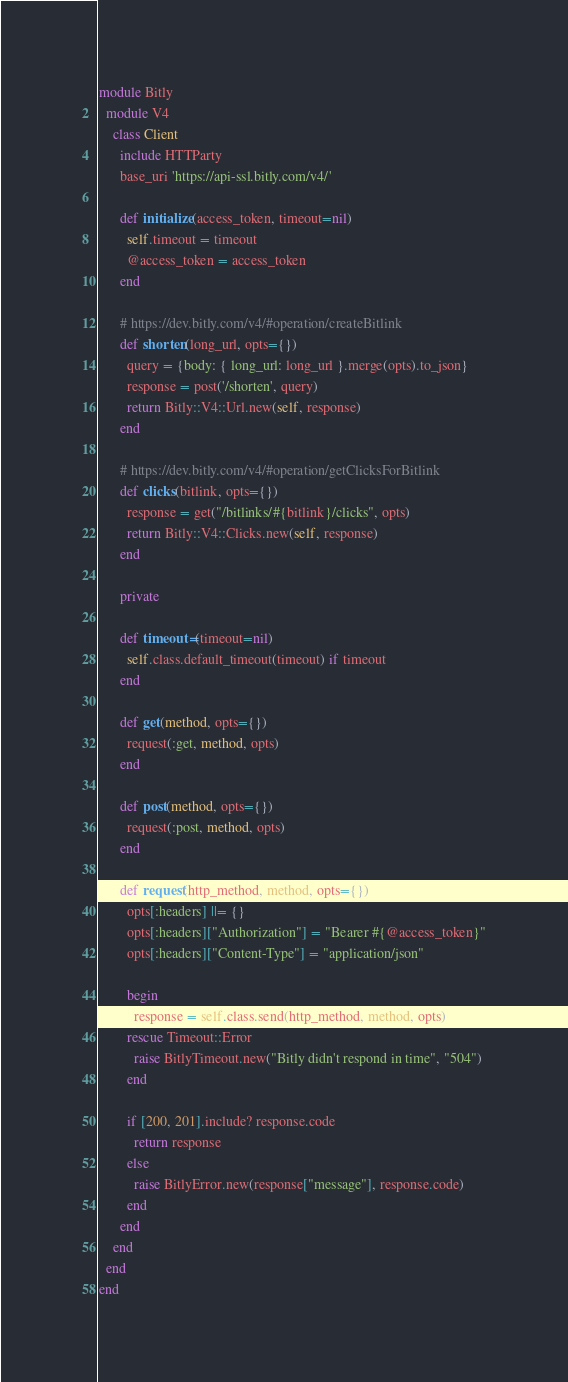Convert code to text. <code><loc_0><loc_0><loc_500><loc_500><_Ruby_>module Bitly
  module V4
    class Client
      include HTTParty
      base_uri 'https://api-ssl.bitly.com/v4/'

      def initialize(access_token, timeout=nil)
        self.timeout = timeout
        @access_token = access_token
      end

      # https://dev.bitly.com/v4/#operation/createBitlink
      def shorten(long_url, opts={})
        query = {body: { long_url: long_url }.merge(opts).to_json}
        response = post('/shorten', query)
        return Bitly::V4::Url.new(self, response)
      end

      # https://dev.bitly.com/v4/#operation/getClicksForBitlink
      def clicks(bitlink, opts={})
        response = get("/bitlinks/#{bitlink}/clicks", opts)
        return Bitly::V4::Clicks.new(self, response)
      end

      private

      def timeout=(timeout=nil)
        self.class.default_timeout(timeout) if timeout
      end

      def get(method, opts={})
        request(:get, method, opts)
      end

      def post(method, opts={})
        request(:post, method, opts)
      end

      def request(http_method, method, opts={})
        opts[:headers] ||= {}
        opts[:headers]["Authorization"] = "Bearer #{@access_token}"
        opts[:headers]["Content-Type"] = "application/json"

        begin
          response = self.class.send(http_method, method, opts)
        rescue Timeout::Error
          raise BitlyTimeout.new("Bitly didn't respond in time", "504")
        end

        if [200, 201].include? response.code
          return response
        else
          raise BitlyError.new(response["message"], response.code)
        end
      end
    end
  end
end
</code> 